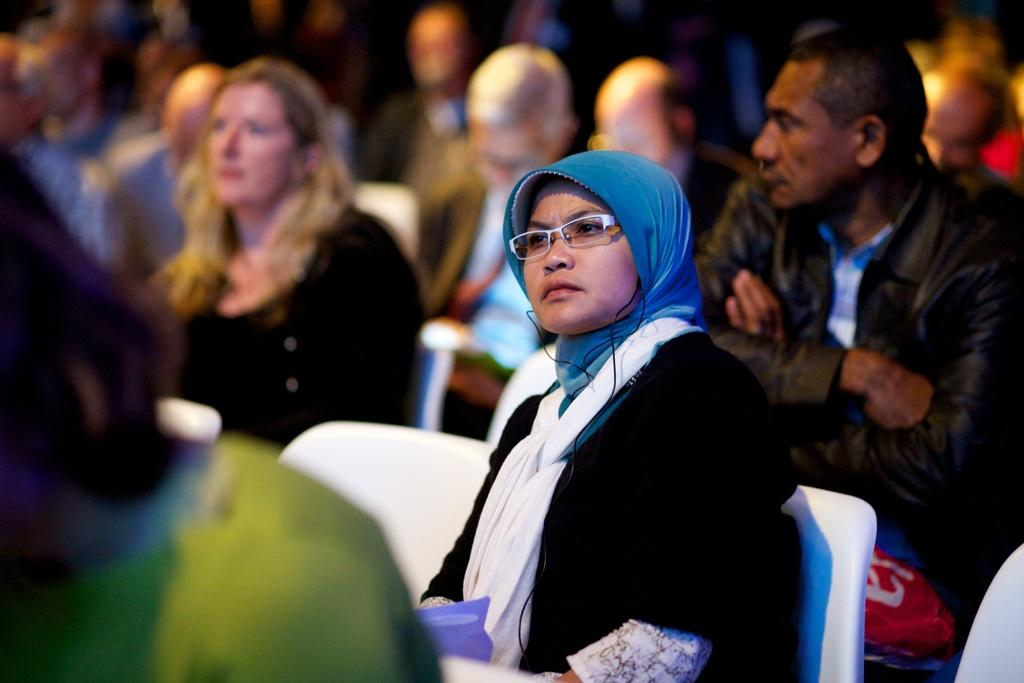Who is the main subject in the image? There is a woman in the image. What is the woman wearing? The woman is wearing glasses. What is the woman doing in the image? The woman is sitting on a chair. What color is the chair the woman is sitting on? The chair is white in color. Can you describe the people in the background of the image? There are people sitting in the background of the image. What type of example does the queen set in the image? There is no queen present in the image, so it is not possible to answer that question. 